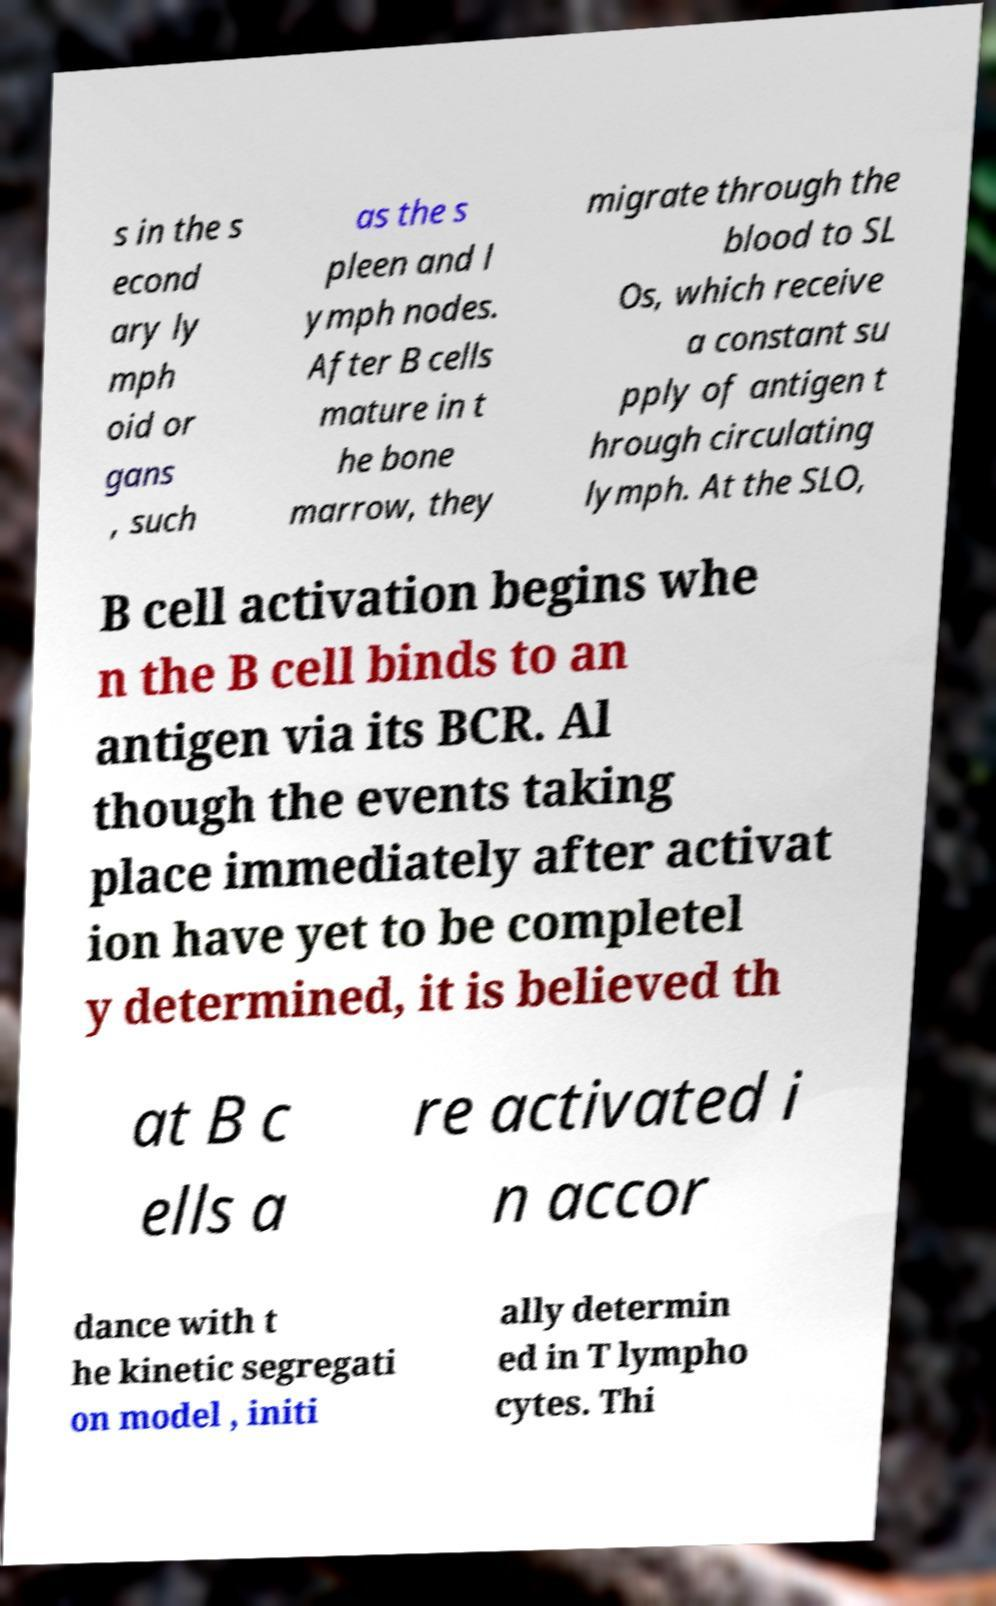For documentation purposes, I need the text within this image transcribed. Could you provide that? s in the s econd ary ly mph oid or gans , such as the s pleen and l ymph nodes. After B cells mature in t he bone marrow, they migrate through the blood to SL Os, which receive a constant su pply of antigen t hrough circulating lymph. At the SLO, B cell activation begins whe n the B cell binds to an antigen via its BCR. Al though the events taking place immediately after activat ion have yet to be completel y determined, it is believed th at B c ells a re activated i n accor dance with t he kinetic segregati on model , initi ally determin ed in T lympho cytes. Thi 